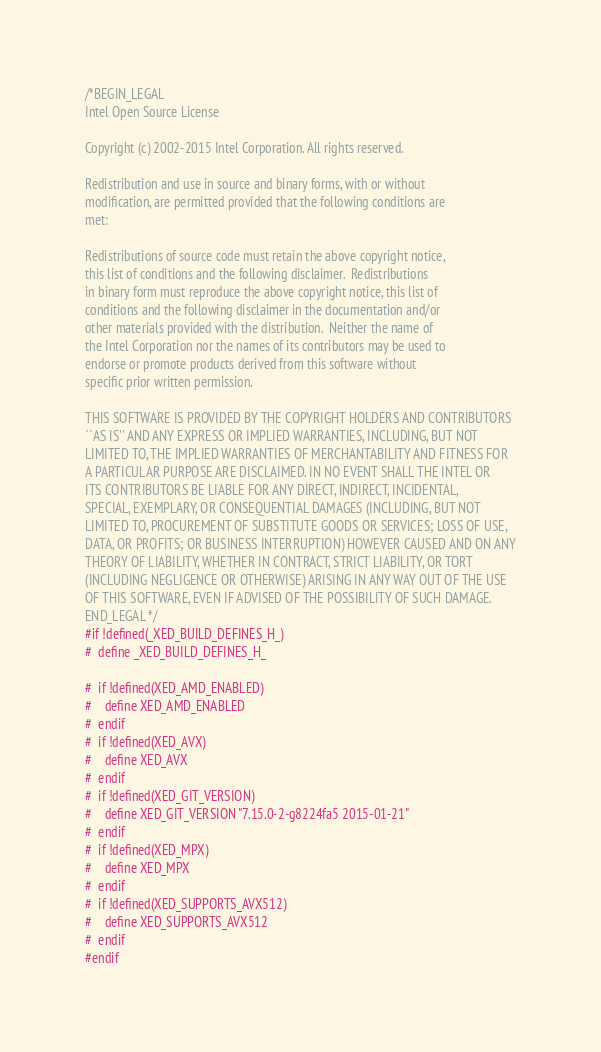<code> <loc_0><loc_0><loc_500><loc_500><_C_>/*BEGIN_LEGAL 
Intel Open Source License 

Copyright (c) 2002-2015 Intel Corporation. All rights reserved.
 
Redistribution and use in source and binary forms, with or without
modification, are permitted provided that the following conditions are
met:

Redistributions of source code must retain the above copyright notice,
this list of conditions and the following disclaimer.  Redistributions
in binary form must reproduce the above copyright notice, this list of
conditions and the following disclaimer in the documentation and/or
other materials provided with the distribution.  Neither the name of
the Intel Corporation nor the names of its contributors may be used to
endorse or promote products derived from this software without
specific prior written permission.
 
THIS SOFTWARE IS PROVIDED BY THE COPYRIGHT HOLDERS AND CONTRIBUTORS
``AS IS'' AND ANY EXPRESS OR IMPLIED WARRANTIES, INCLUDING, BUT NOT
LIMITED TO, THE IMPLIED WARRANTIES OF MERCHANTABILITY AND FITNESS FOR
A PARTICULAR PURPOSE ARE DISCLAIMED. IN NO EVENT SHALL THE INTEL OR
ITS CONTRIBUTORS BE LIABLE FOR ANY DIRECT, INDIRECT, INCIDENTAL,
SPECIAL, EXEMPLARY, OR CONSEQUENTIAL DAMAGES (INCLUDING, BUT NOT
LIMITED TO, PROCUREMENT OF SUBSTITUTE GOODS OR SERVICES; LOSS OF USE,
DATA, OR PROFITS; OR BUSINESS INTERRUPTION) HOWEVER CAUSED AND ON ANY
THEORY OF LIABILITY, WHETHER IN CONTRACT, STRICT LIABILITY, OR TORT
(INCLUDING NEGLIGENCE OR OTHERWISE) ARISING IN ANY WAY OUT OF THE USE
OF THIS SOFTWARE, EVEN IF ADVISED OF THE POSSIBILITY OF SUCH DAMAGE.
END_LEGAL */
#if !defined(_XED_BUILD_DEFINES_H_)
#  define _XED_BUILD_DEFINES_H_

#  if !defined(XED_AMD_ENABLED)
#    define XED_AMD_ENABLED
#  endif
#  if !defined(XED_AVX)
#    define XED_AVX
#  endif
#  if !defined(XED_GIT_VERSION)
#    define XED_GIT_VERSION "7.15.0-2-g8224fa5 2015-01-21"
#  endif
#  if !defined(XED_MPX)
#    define XED_MPX
#  endif
#  if !defined(XED_SUPPORTS_AVX512)
#    define XED_SUPPORTS_AVX512
#  endif
#endif
</code> 